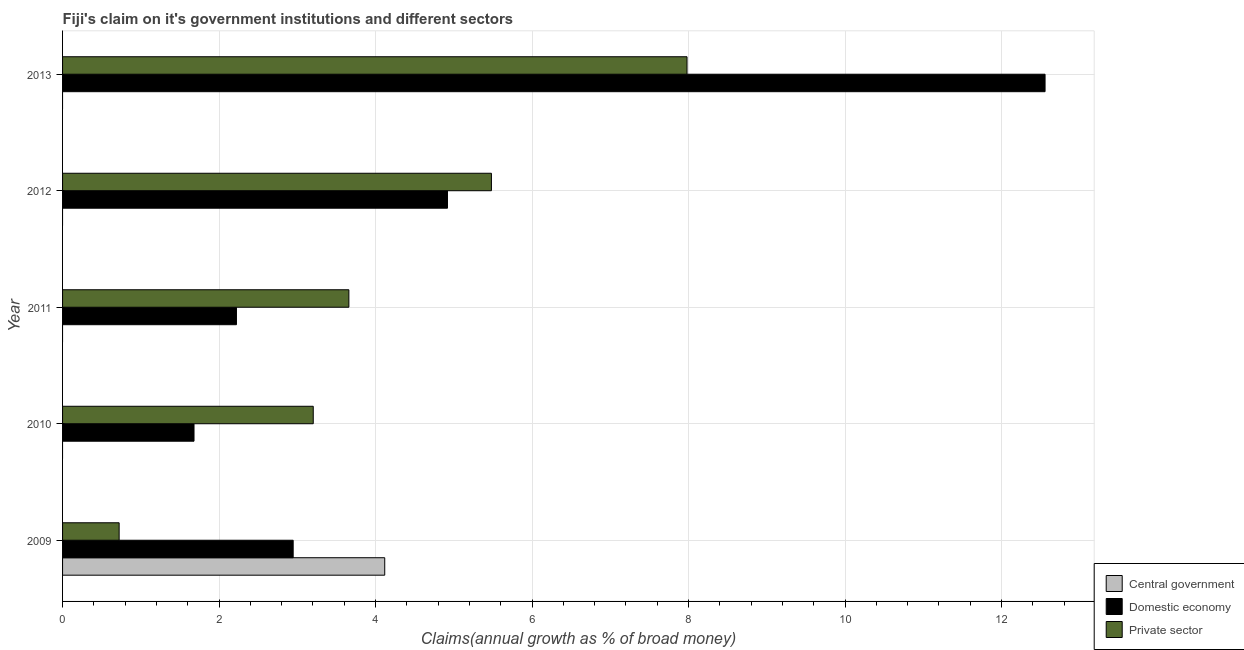How many different coloured bars are there?
Your answer should be very brief. 3. Are the number of bars on each tick of the Y-axis equal?
Your answer should be compact. No. How many bars are there on the 1st tick from the top?
Provide a succinct answer. 2. In how many cases, is the number of bars for a given year not equal to the number of legend labels?
Your answer should be very brief. 4. Across all years, what is the maximum percentage of claim on the domestic economy?
Ensure brevity in your answer.  12.56. Across all years, what is the minimum percentage of claim on the domestic economy?
Keep it short and to the point. 1.68. In which year was the percentage of claim on the private sector maximum?
Provide a succinct answer. 2013. What is the total percentage of claim on the domestic economy in the graph?
Offer a very short reply. 24.32. What is the difference between the percentage of claim on the domestic economy in 2010 and that in 2013?
Make the answer very short. -10.88. What is the difference between the percentage of claim on the domestic economy in 2011 and the percentage of claim on the private sector in 2013?
Provide a succinct answer. -5.76. What is the average percentage of claim on the domestic economy per year?
Your answer should be very brief. 4.87. In the year 2013, what is the difference between the percentage of claim on the private sector and percentage of claim on the domestic economy?
Provide a short and direct response. -4.58. In how many years, is the percentage of claim on the domestic economy greater than 7.2 %?
Your response must be concise. 1. What is the ratio of the percentage of claim on the private sector in 2010 to that in 2012?
Ensure brevity in your answer.  0.58. What is the difference between the highest and the second highest percentage of claim on the domestic economy?
Offer a terse response. 7.64. What is the difference between the highest and the lowest percentage of claim on the central government?
Provide a short and direct response. 4.12. Is the sum of the percentage of claim on the private sector in 2012 and 2013 greater than the maximum percentage of claim on the central government across all years?
Keep it short and to the point. Yes. Are all the bars in the graph horizontal?
Your answer should be very brief. Yes. How many years are there in the graph?
Keep it short and to the point. 5. What is the difference between two consecutive major ticks on the X-axis?
Provide a succinct answer. 2. How many legend labels are there?
Offer a very short reply. 3. How are the legend labels stacked?
Offer a very short reply. Vertical. What is the title of the graph?
Your answer should be very brief. Fiji's claim on it's government institutions and different sectors. What is the label or title of the X-axis?
Your answer should be compact. Claims(annual growth as % of broad money). What is the label or title of the Y-axis?
Provide a succinct answer. Year. What is the Claims(annual growth as % of broad money) in Central government in 2009?
Make the answer very short. 4.12. What is the Claims(annual growth as % of broad money) in Domestic economy in 2009?
Offer a very short reply. 2.95. What is the Claims(annual growth as % of broad money) of Private sector in 2009?
Ensure brevity in your answer.  0.72. What is the Claims(annual growth as % of broad money) in Domestic economy in 2010?
Provide a succinct answer. 1.68. What is the Claims(annual growth as % of broad money) in Private sector in 2010?
Ensure brevity in your answer.  3.2. What is the Claims(annual growth as % of broad money) in Domestic economy in 2011?
Provide a succinct answer. 2.22. What is the Claims(annual growth as % of broad money) in Private sector in 2011?
Ensure brevity in your answer.  3.66. What is the Claims(annual growth as % of broad money) of Central government in 2012?
Provide a succinct answer. 0. What is the Claims(annual growth as % of broad money) in Domestic economy in 2012?
Your answer should be very brief. 4.92. What is the Claims(annual growth as % of broad money) of Private sector in 2012?
Offer a terse response. 5.48. What is the Claims(annual growth as % of broad money) of Central government in 2013?
Provide a short and direct response. 0. What is the Claims(annual growth as % of broad money) of Domestic economy in 2013?
Provide a succinct answer. 12.56. What is the Claims(annual growth as % of broad money) of Private sector in 2013?
Offer a terse response. 7.98. Across all years, what is the maximum Claims(annual growth as % of broad money) in Central government?
Keep it short and to the point. 4.12. Across all years, what is the maximum Claims(annual growth as % of broad money) in Domestic economy?
Your answer should be compact. 12.56. Across all years, what is the maximum Claims(annual growth as % of broad money) of Private sector?
Your answer should be very brief. 7.98. Across all years, what is the minimum Claims(annual growth as % of broad money) in Central government?
Offer a terse response. 0. Across all years, what is the minimum Claims(annual growth as % of broad money) of Domestic economy?
Offer a very short reply. 1.68. Across all years, what is the minimum Claims(annual growth as % of broad money) of Private sector?
Your answer should be very brief. 0.72. What is the total Claims(annual growth as % of broad money) in Central government in the graph?
Your answer should be compact. 4.12. What is the total Claims(annual growth as % of broad money) of Domestic economy in the graph?
Offer a terse response. 24.32. What is the total Claims(annual growth as % of broad money) in Private sector in the graph?
Give a very brief answer. 21.05. What is the difference between the Claims(annual growth as % of broad money) of Domestic economy in 2009 and that in 2010?
Provide a short and direct response. 1.27. What is the difference between the Claims(annual growth as % of broad money) of Private sector in 2009 and that in 2010?
Provide a succinct answer. -2.48. What is the difference between the Claims(annual growth as % of broad money) in Domestic economy in 2009 and that in 2011?
Provide a succinct answer. 0.72. What is the difference between the Claims(annual growth as % of broad money) of Private sector in 2009 and that in 2011?
Your response must be concise. -2.94. What is the difference between the Claims(annual growth as % of broad money) of Domestic economy in 2009 and that in 2012?
Offer a very short reply. -1.97. What is the difference between the Claims(annual growth as % of broad money) of Private sector in 2009 and that in 2012?
Your answer should be compact. -4.76. What is the difference between the Claims(annual growth as % of broad money) in Domestic economy in 2009 and that in 2013?
Offer a very short reply. -9.61. What is the difference between the Claims(annual growth as % of broad money) in Private sector in 2009 and that in 2013?
Provide a short and direct response. -7.26. What is the difference between the Claims(annual growth as % of broad money) in Domestic economy in 2010 and that in 2011?
Provide a short and direct response. -0.54. What is the difference between the Claims(annual growth as % of broad money) in Private sector in 2010 and that in 2011?
Provide a succinct answer. -0.46. What is the difference between the Claims(annual growth as % of broad money) of Domestic economy in 2010 and that in 2012?
Provide a succinct answer. -3.24. What is the difference between the Claims(annual growth as % of broad money) of Private sector in 2010 and that in 2012?
Provide a succinct answer. -2.28. What is the difference between the Claims(annual growth as % of broad money) of Domestic economy in 2010 and that in 2013?
Provide a short and direct response. -10.88. What is the difference between the Claims(annual growth as % of broad money) of Private sector in 2010 and that in 2013?
Offer a terse response. -4.78. What is the difference between the Claims(annual growth as % of broad money) of Domestic economy in 2011 and that in 2012?
Provide a short and direct response. -2.7. What is the difference between the Claims(annual growth as % of broad money) of Private sector in 2011 and that in 2012?
Offer a very short reply. -1.82. What is the difference between the Claims(annual growth as % of broad money) in Domestic economy in 2011 and that in 2013?
Keep it short and to the point. -10.33. What is the difference between the Claims(annual growth as % of broad money) of Private sector in 2011 and that in 2013?
Provide a short and direct response. -4.32. What is the difference between the Claims(annual growth as % of broad money) in Domestic economy in 2012 and that in 2013?
Provide a succinct answer. -7.64. What is the difference between the Claims(annual growth as % of broad money) of Private sector in 2012 and that in 2013?
Provide a succinct answer. -2.5. What is the difference between the Claims(annual growth as % of broad money) in Central government in 2009 and the Claims(annual growth as % of broad money) in Domestic economy in 2010?
Ensure brevity in your answer.  2.44. What is the difference between the Claims(annual growth as % of broad money) of Central government in 2009 and the Claims(annual growth as % of broad money) of Private sector in 2010?
Your response must be concise. 0.91. What is the difference between the Claims(annual growth as % of broad money) of Domestic economy in 2009 and the Claims(annual growth as % of broad money) of Private sector in 2010?
Your answer should be compact. -0.26. What is the difference between the Claims(annual growth as % of broad money) in Central government in 2009 and the Claims(annual growth as % of broad money) in Domestic economy in 2011?
Make the answer very short. 1.89. What is the difference between the Claims(annual growth as % of broad money) of Central government in 2009 and the Claims(annual growth as % of broad money) of Private sector in 2011?
Keep it short and to the point. 0.46. What is the difference between the Claims(annual growth as % of broad money) of Domestic economy in 2009 and the Claims(annual growth as % of broad money) of Private sector in 2011?
Your response must be concise. -0.71. What is the difference between the Claims(annual growth as % of broad money) in Central government in 2009 and the Claims(annual growth as % of broad money) in Domestic economy in 2012?
Provide a short and direct response. -0.8. What is the difference between the Claims(annual growth as % of broad money) in Central government in 2009 and the Claims(annual growth as % of broad money) in Private sector in 2012?
Your answer should be compact. -1.36. What is the difference between the Claims(annual growth as % of broad money) in Domestic economy in 2009 and the Claims(annual growth as % of broad money) in Private sector in 2012?
Make the answer very short. -2.53. What is the difference between the Claims(annual growth as % of broad money) in Central government in 2009 and the Claims(annual growth as % of broad money) in Domestic economy in 2013?
Make the answer very short. -8.44. What is the difference between the Claims(annual growth as % of broad money) of Central government in 2009 and the Claims(annual growth as % of broad money) of Private sector in 2013?
Provide a succinct answer. -3.86. What is the difference between the Claims(annual growth as % of broad money) in Domestic economy in 2009 and the Claims(annual growth as % of broad money) in Private sector in 2013?
Your answer should be compact. -5.03. What is the difference between the Claims(annual growth as % of broad money) of Domestic economy in 2010 and the Claims(annual growth as % of broad money) of Private sector in 2011?
Your answer should be compact. -1.98. What is the difference between the Claims(annual growth as % of broad money) in Domestic economy in 2010 and the Claims(annual growth as % of broad money) in Private sector in 2012?
Your response must be concise. -3.8. What is the difference between the Claims(annual growth as % of broad money) in Domestic economy in 2010 and the Claims(annual growth as % of broad money) in Private sector in 2013?
Ensure brevity in your answer.  -6.3. What is the difference between the Claims(annual growth as % of broad money) of Domestic economy in 2011 and the Claims(annual growth as % of broad money) of Private sector in 2012?
Your answer should be very brief. -3.26. What is the difference between the Claims(annual growth as % of broad money) in Domestic economy in 2011 and the Claims(annual growth as % of broad money) in Private sector in 2013?
Provide a short and direct response. -5.76. What is the difference between the Claims(annual growth as % of broad money) of Domestic economy in 2012 and the Claims(annual growth as % of broad money) of Private sector in 2013?
Offer a terse response. -3.06. What is the average Claims(annual growth as % of broad money) in Central government per year?
Make the answer very short. 0.82. What is the average Claims(annual growth as % of broad money) of Domestic economy per year?
Your response must be concise. 4.86. What is the average Claims(annual growth as % of broad money) in Private sector per year?
Your answer should be very brief. 4.21. In the year 2009, what is the difference between the Claims(annual growth as % of broad money) in Central government and Claims(annual growth as % of broad money) in Domestic economy?
Give a very brief answer. 1.17. In the year 2009, what is the difference between the Claims(annual growth as % of broad money) in Central government and Claims(annual growth as % of broad money) in Private sector?
Your response must be concise. 3.39. In the year 2009, what is the difference between the Claims(annual growth as % of broad money) of Domestic economy and Claims(annual growth as % of broad money) of Private sector?
Your response must be concise. 2.22. In the year 2010, what is the difference between the Claims(annual growth as % of broad money) in Domestic economy and Claims(annual growth as % of broad money) in Private sector?
Provide a short and direct response. -1.52. In the year 2011, what is the difference between the Claims(annual growth as % of broad money) of Domestic economy and Claims(annual growth as % of broad money) of Private sector?
Your response must be concise. -1.44. In the year 2012, what is the difference between the Claims(annual growth as % of broad money) in Domestic economy and Claims(annual growth as % of broad money) in Private sector?
Offer a terse response. -0.56. In the year 2013, what is the difference between the Claims(annual growth as % of broad money) in Domestic economy and Claims(annual growth as % of broad money) in Private sector?
Give a very brief answer. 4.58. What is the ratio of the Claims(annual growth as % of broad money) in Domestic economy in 2009 to that in 2010?
Your answer should be compact. 1.75. What is the ratio of the Claims(annual growth as % of broad money) in Private sector in 2009 to that in 2010?
Ensure brevity in your answer.  0.23. What is the ratio of the Claims(annual growth as % of broad money) of Domestic economy in 2009 to that in 2011?
Offer a very short reply. 1.33. What is the ratio of the Claims(annual growth as % of broad money) in Private sector in 2009 to that in 2011?
Ensure brevity in your answer.  0.2. What is the ratio of the Claims(annual growth as % of broad money) in Domestic economy in 2009 to that in 2012?
Your response must be concise. 0.6. What is the ratio of the Claims(annual growth as % of broad money) of Private sector in 2009 to that in 2012?
Your response must be concise. 0.13. What is the ratio of the Claims(annual growth as % of broad money) in Domestic economy in 2009 to that in 2013?
Offer a terse response. 0.23. What is the ratio of the Claims(annual growth as % of broad money) in Private sector in 2009 to that in 2013?
Make the answer very short. 0.09. What is the ratio of the Claims(annual growth as % of broad money) of Domestic economy in 2010 to that in 2011?
Offer a very short reply. 0.76. What is the ratio of the Claims(annual growth as % of broad money) of Private sector in 2010 to that in 2011?
Offer a very short reply. 0.88. What is the ratio of the Claims(annual growth as % of broad money) in Domestic economy in 2010 to that in 2012?
Your answer should be very brief. 0.34. What is the ratio of the Claims(annual growth as % of broad money) in Private sector in 2010 to that in 2012?
Offer a very short reply. 0.58. What is the ratio of the Claims(annual growth as % of broad money) of Domestic economy in 2010 to that in 2013?
Ensure brevity in your answer.  0.13. What is the ratio of the Claims(annual growth as % of broad money) in Private sector in 2010 to that in 2013?
Your answer should be compact. 0.4. What is the ratio of the Claims(annual growth as % of broad money) of Domestic economy in 2011 to that in 2012?
Your answer should be very brief. 0.45. What is the ratio of the Claims(annual growth as % of broad money) in Private sector in 2011 to that in 2012?
Give a very brief answer. 0.67. What is the ratio of the Claims(annual growth as % of broad money) of Domestic economy in 2011 to that in 2013?
Make the answer very short. 0.18. What is the ratio of the Claims(annual growth as % of broad money) of Private sector in 2011 to that in 2013?
Your answer should be very brief. 0.46. What is the ratio of the Claims(annual growth as % of broad money) of Domestic economy in 2012 to that in 2013?
Offer a terse response. 0.39. What is the ratio of the Claims(annual growth as % of broad money) in Private sector in 2012 to that in 2013?
Provide a short and direct response. 0.69. What is the difference between the highest and the second highest Claims(annual growth as % of broad money) of Domestic economy?
Your response must be concise. 7.64. What is the difference between the highest and the second highest Claims(annual growth as % of broad money) in Private sector?
Provide a short and direct response. 2.5. What is the difference between the highest and the lowest Claims(annual growth as % of broad money) in Central government?
Your answer should be compact. 4.12. What is the difference between the highest and the lowest Claims(annual growth as % of broad money) in Domestic economy?
Offer a terse response. 10.88. What is the difference between the highest and the lowest Claims(annual growth as % of broad money) in Private sector?
Ensure brevity in your answer.  7.26. 